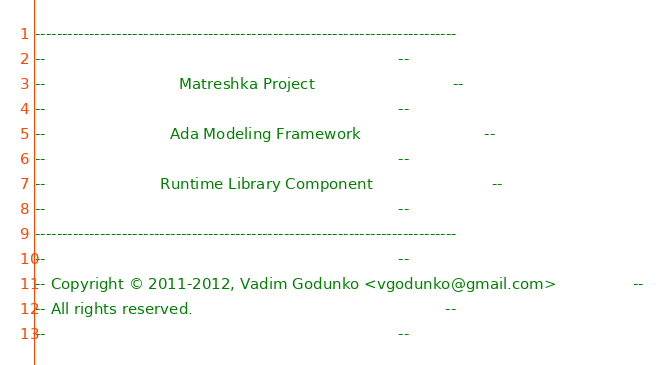Convert code to text. <code><loc_0><loc_0><loc_500><loc_500><_Ada_>------------------------------------------------------------------------------
--                                                                          --
--                            Matreshka Project                             --
--                                                                          --
--                          Ada Modeling Framework                          --
--                                                                          --
--                        Runtime Library Component                         --
--                                                                          --
------------------------------------------------------------------------------
--                                                                          --
-- Copyright © 2011-2012, Vadim Godunko <vgodunko@gmail.com>                --
-- All rights reserved.                                                     --
--                                                                          --</code> 